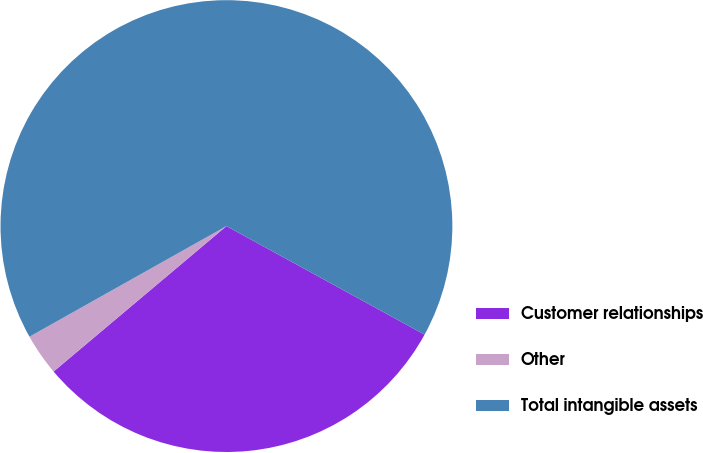Convert chart to OTSL. <chart><loc_0><loc_0><loc_500><loc_500><pie_chart><fcel>Customer relationships<fcel>Other<fcel>Total intangible assets<nl><fcel>30.89%<fcel>2.99%<fcel>66.12%<nl></chart> 